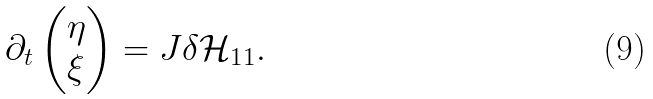<formula> <loc_0><loc_0><loc_500><loc_500>\partial _ { t } \begin{pmatrix} \eta \\ \xi \end{pmatrix} = J \delta \mathcal { H } _ { 1 1 } .</formula> 